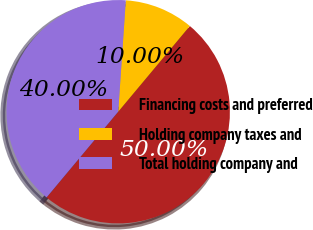Convert chart to OTSL. <chart><loc_0><loc_0><loc_500><loc_500><pie_chart><fcel>Financing costs and preferred<fcel>Holding company taxes and<fcel>Total holding company and<nl><fcel>50.0%<fcel>10.0%<fcel>40.0%<nl></chart> 